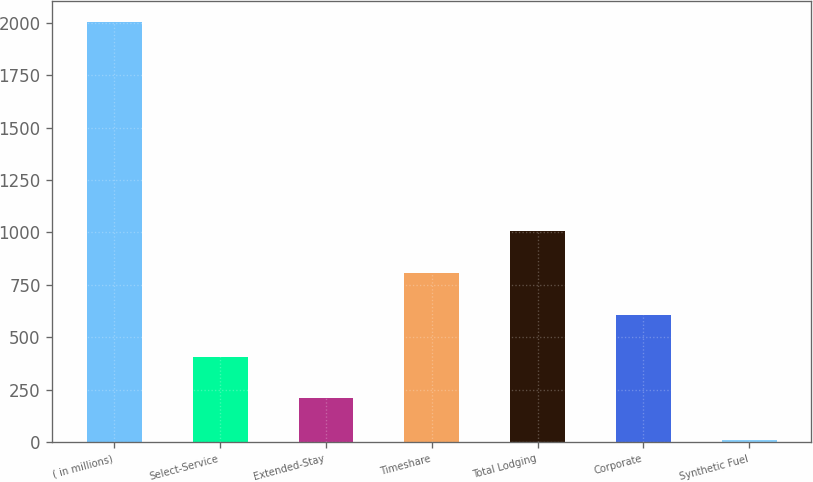Convert chart to OTSL. <chart><loc_0><loc_0><loc_500><loc_500><bar_chart><fcel>( in millions)<fcel>Select-Service<fcel>Extended-Stay<fcel>Timeshare<fcel>Total Lodging<fcel>Corporate<fcel>Synthetic Fuel<nl><fcel>2004<fcel>407.2<fcel>207.6<fcel>806.4<fcel>1006<fcel>606.8<fcel>8<nl></chart> 